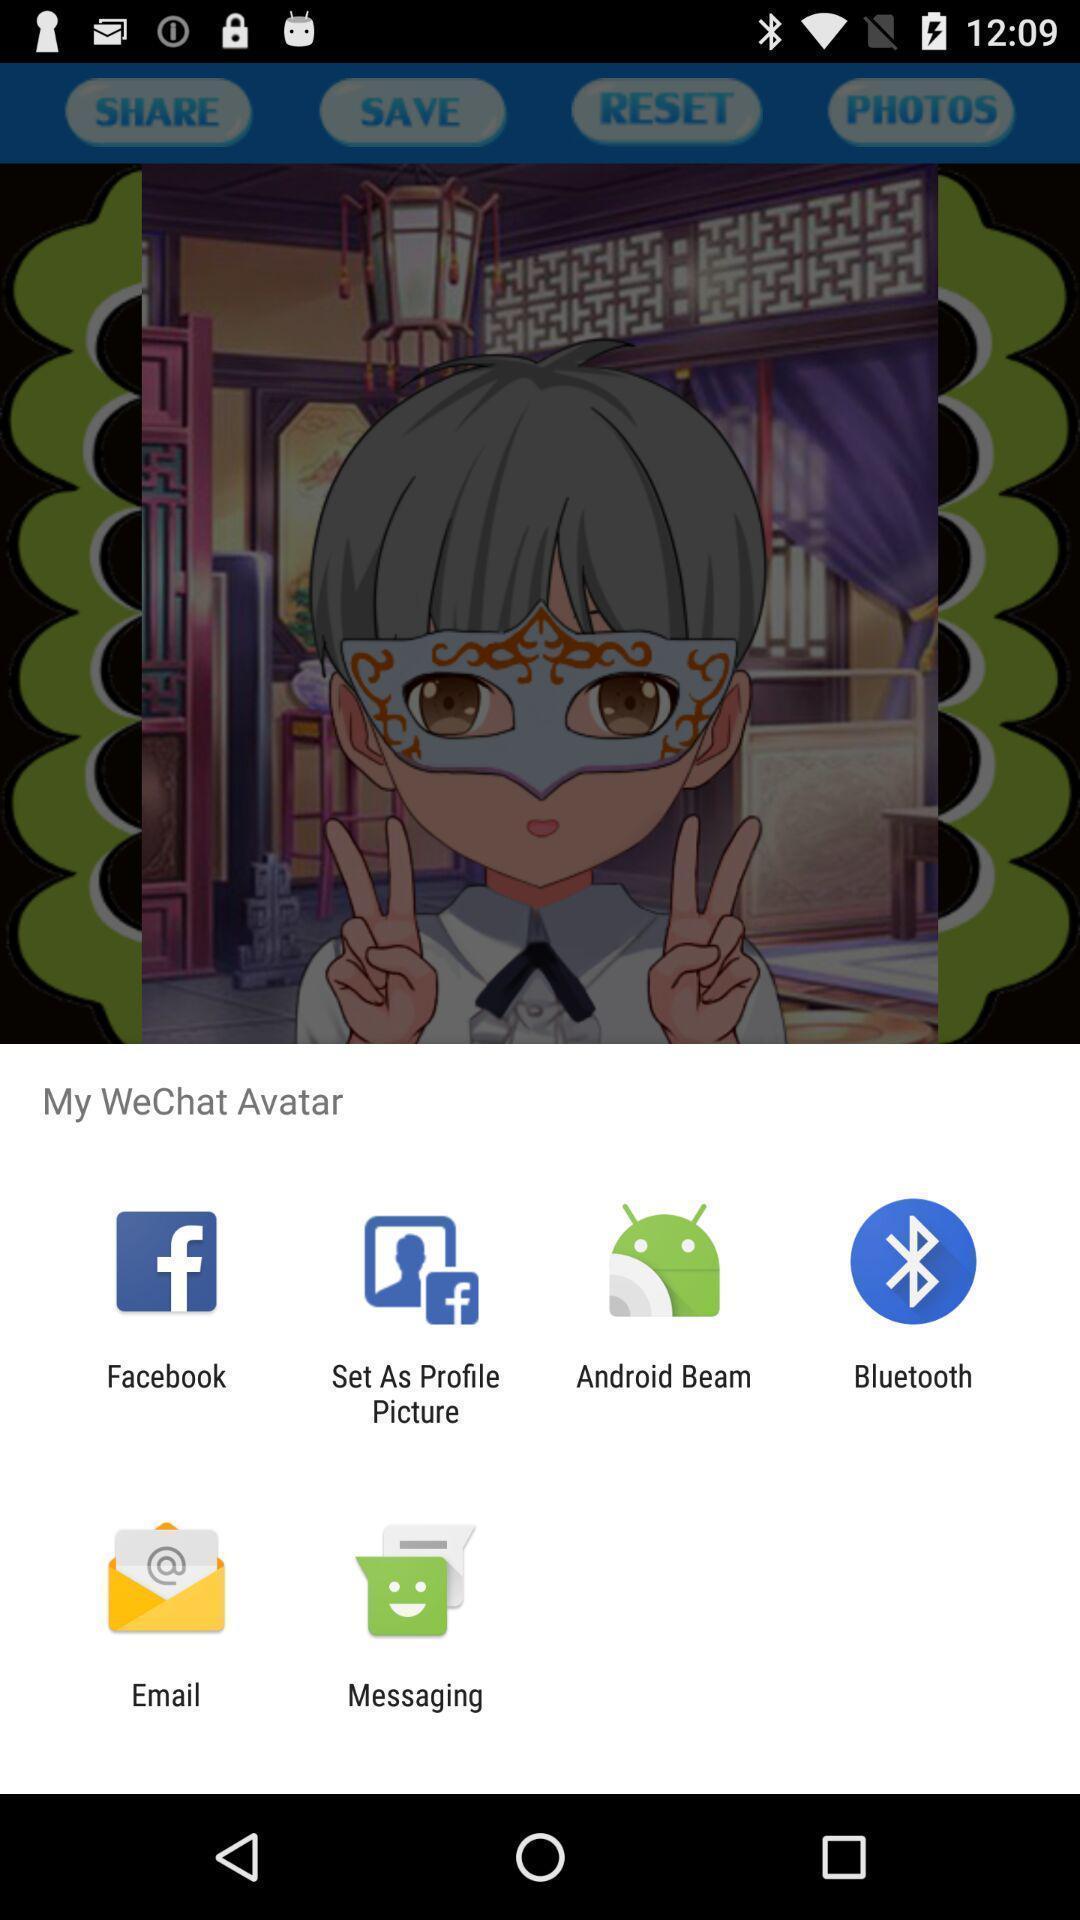Describe the content in this image. Pop up displaying options to share avatars. 